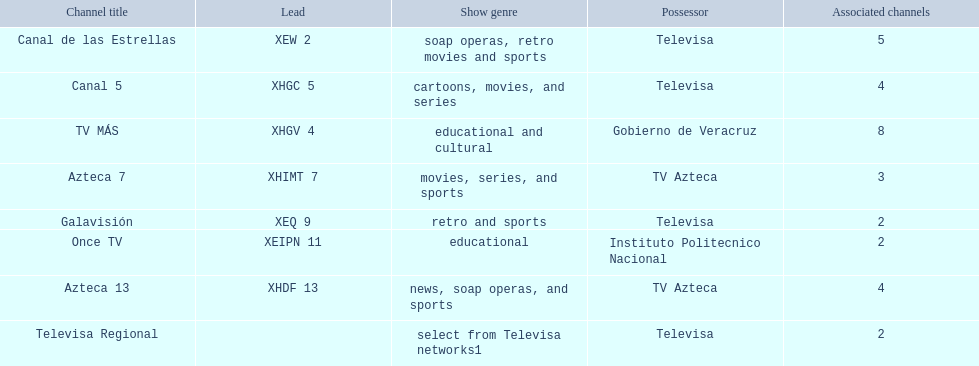Which owner has the most networks? Televisa. 